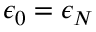<formula> <loc_0><loc_0><loc_500><loc_500>\epsilon _ { 0 } = \epsilon _ { N }</formula> 